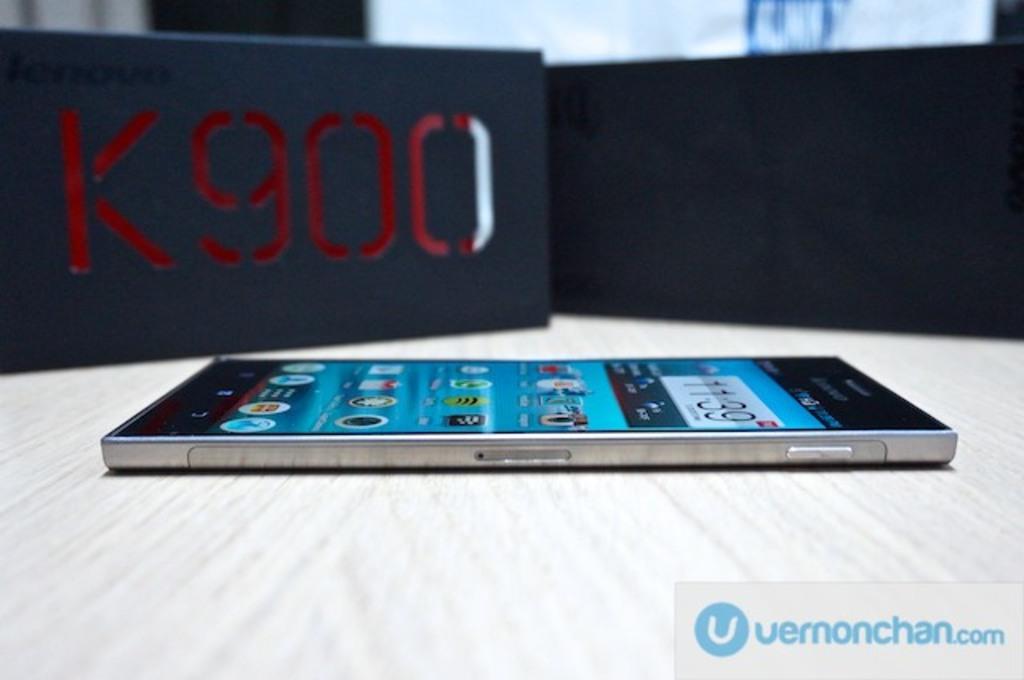What time is displayed on the screen?
Make the answer very short. 11:39. 